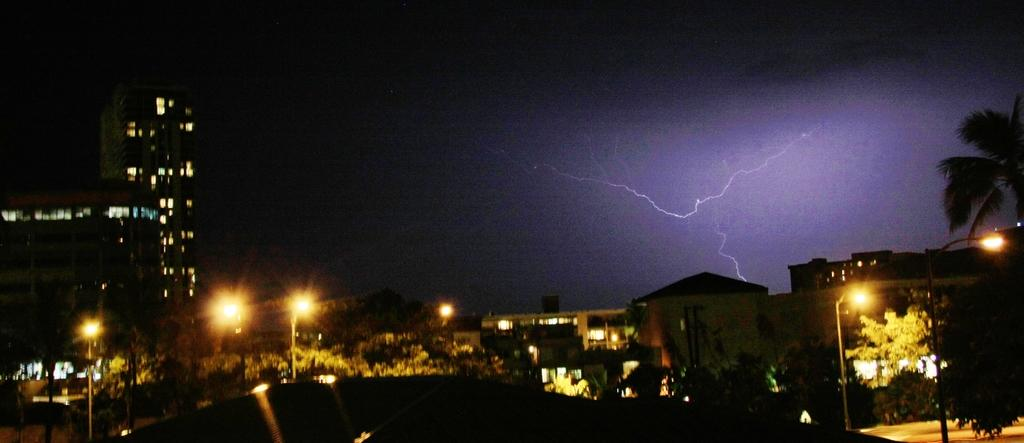What type of structures can be seen in the image? There are buildings in the image. What else can be seen in the image besides buildings? There are lamp poles and trees at the bottom side of the image. What is the condition of the sky in the image? There is a thundering in the sky. What type of shade is being used to cover the pan in the image? There is no shade or pan present in the image. What sense is being evoked by the image? The image does not evoke a specific sense, as it only shows buildings, lamp poles, trees, and a thundering sky. 